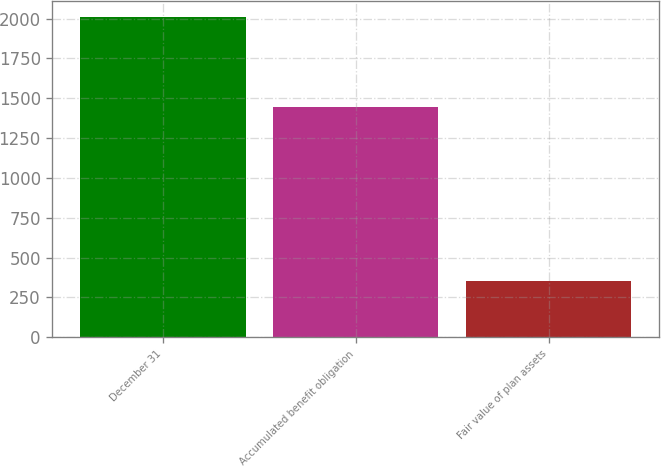Convert chart to OTSL. <chart><loc_0><loc_0><loc_500><loc_500><bar_chart><fcel>December 31<fcel>Accumulated benefit obligation<fcel>Fair value of plan assets<nl><fcel>2013<fcel>1446<fcel>351<nl></chart> 